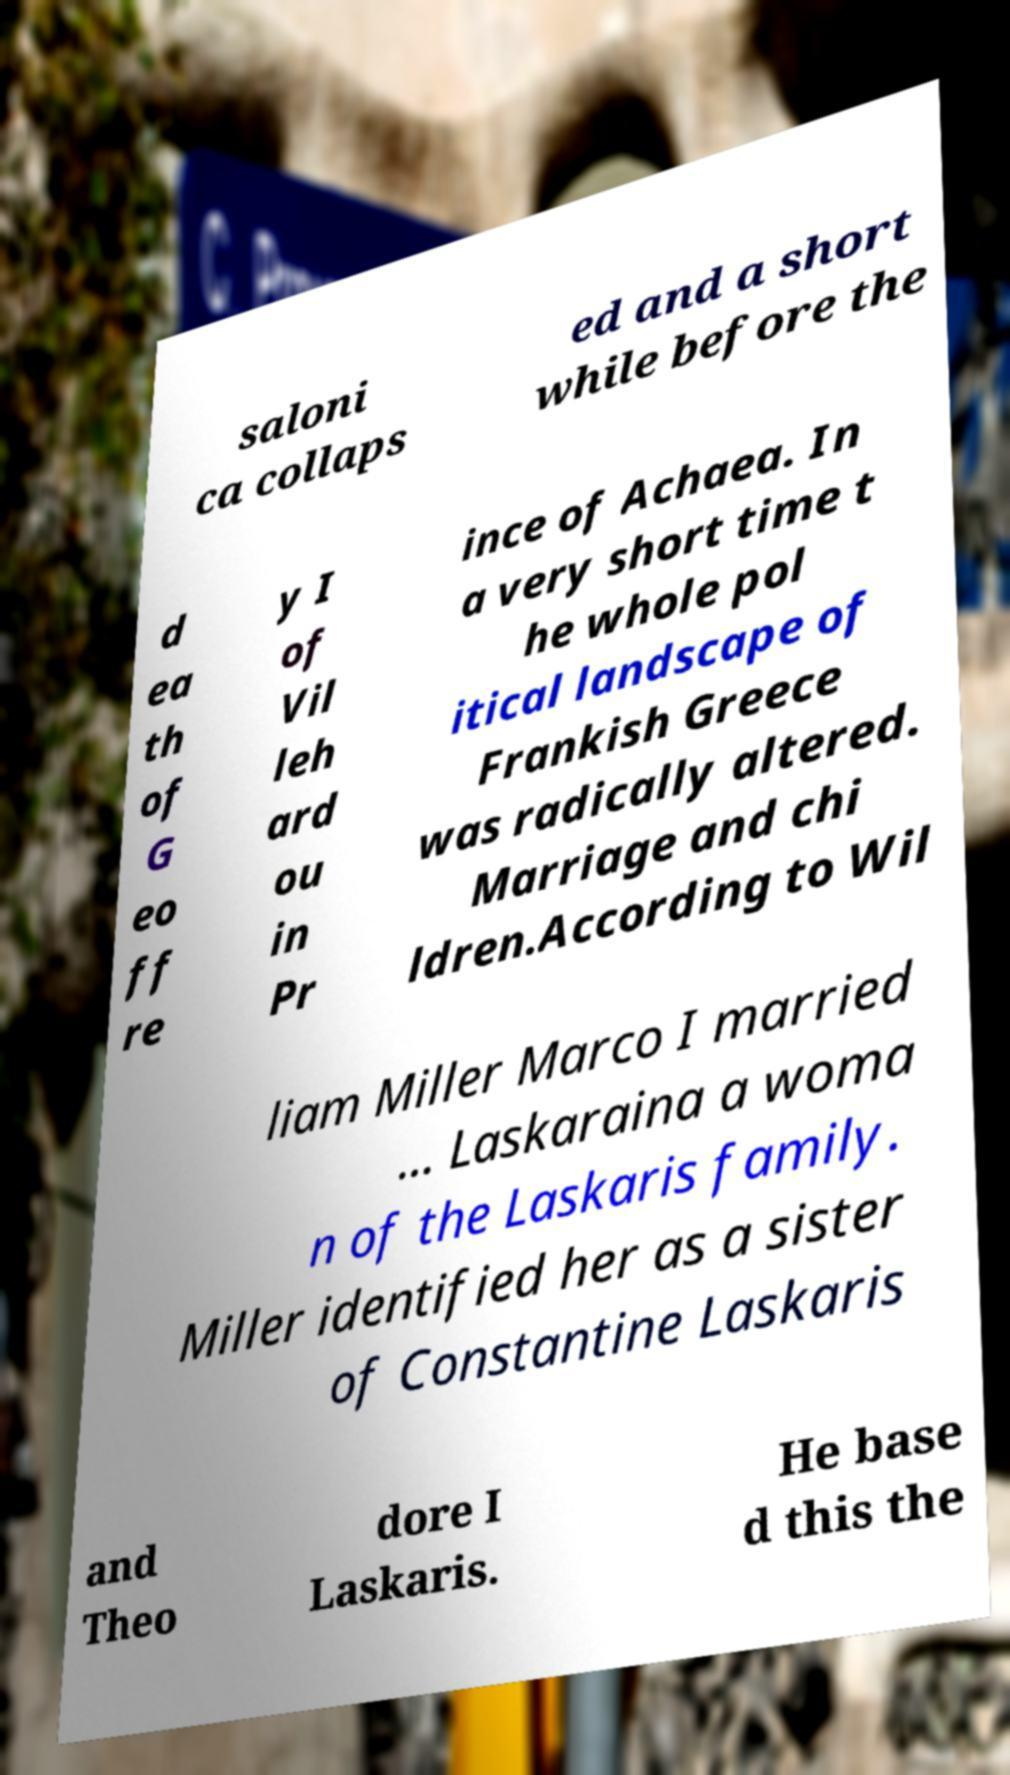Please read and relay the text visible in this image. What does it say? saloni ca collaps ed and a short while before the d ea th of G eo ff re y I of Vil leh ard ou in Pr ince of Achaea. In a very short time t he whole pol itical landscape of Frankish Greece was radically altered. Marriage and chi ldren.According to Wil liam Miller Marco I married ... Laskaraina a woma n of the Laskaris family. Miller identified her as a sister of Constantine Laskaris and Theo dore I Laskaris. He base d this the 